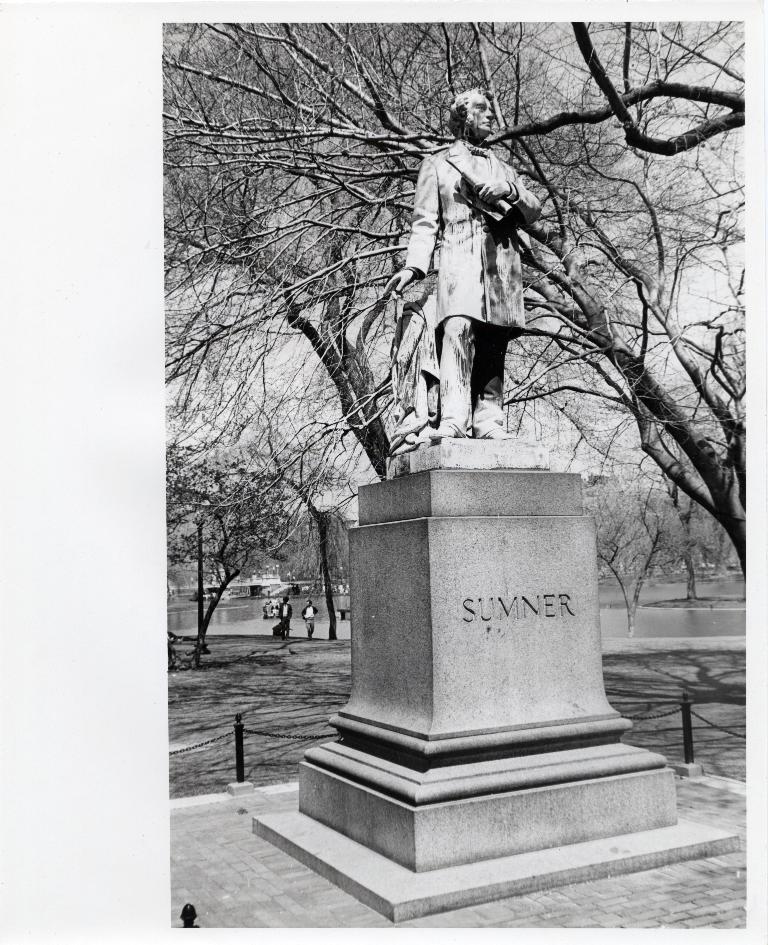Can you describe this image briefly? In this picture we can see the statue of a person. He is standing on this stone. In the background there are two persons were standing near to the trees. In the left background we can see the buildings and water. On the left there is a sky. 